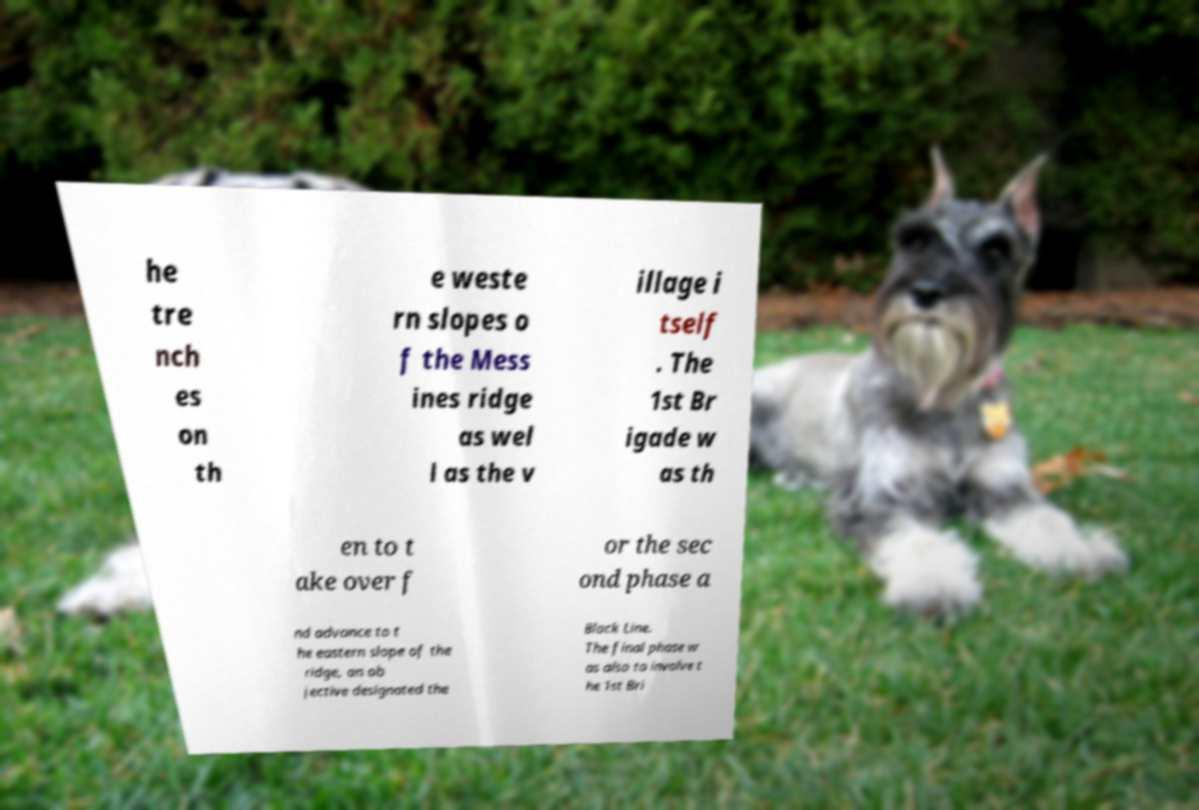Could you extract and type out the text from this image? he tre nch es on th e weste rn slopes o f the Mess ines ridge as wel l as the v illage i tself . The 1st Br igade w as th en to t ake over f or the sec ond phase a nd advance to t he eastern slope of the ridge, an ob jective designated the Black Line. The final phase w as also to involve t he 1st Bri 